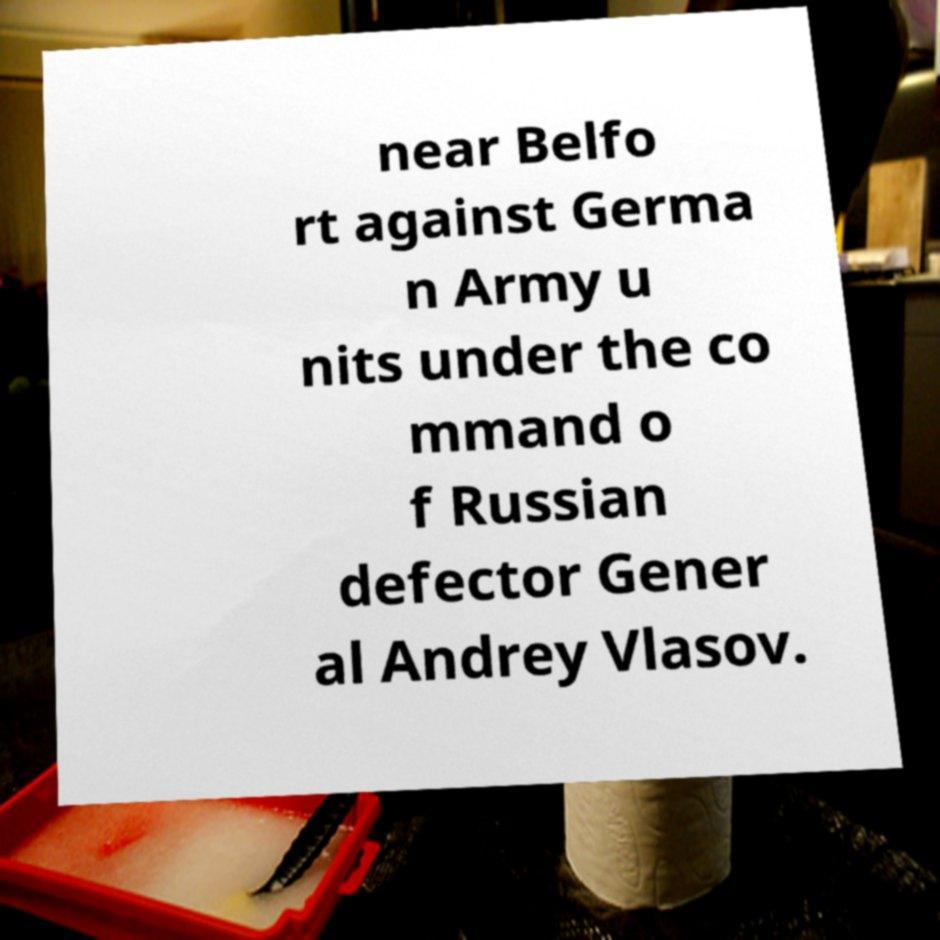Please identify and transcribe the text found in this image. near Belfo rt against Germa n Army u nits under the co mmand o f Russian defector Gener al Andrey Vlasov. 